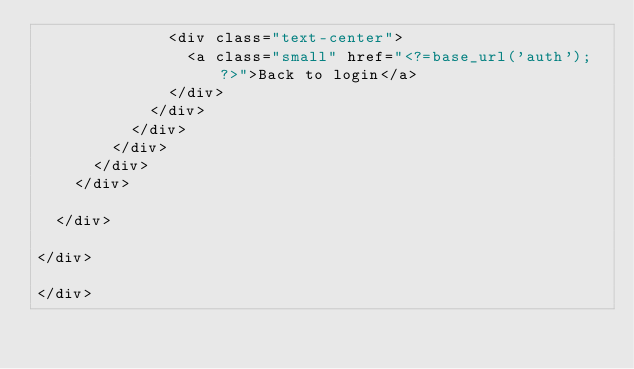<code> <loc_0><loc_0><loc_500><loc_500><_PHP_>              <div class="text-center">
                <a class="small" href="<?=base_url('auth'); ?>">Back to login</a>
              </div>
            </div>
          </div>
        </div>
      </div>
    </div>

  </div>

</div>

</div>

</code> 